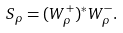<formula> <loc_0><loc_0><loc_500><loc_500>S _ { \rho } = ( W _ { \rho } ^ { + } ) ^ { * } W _ { \rho } ^ { - } .</formula> 